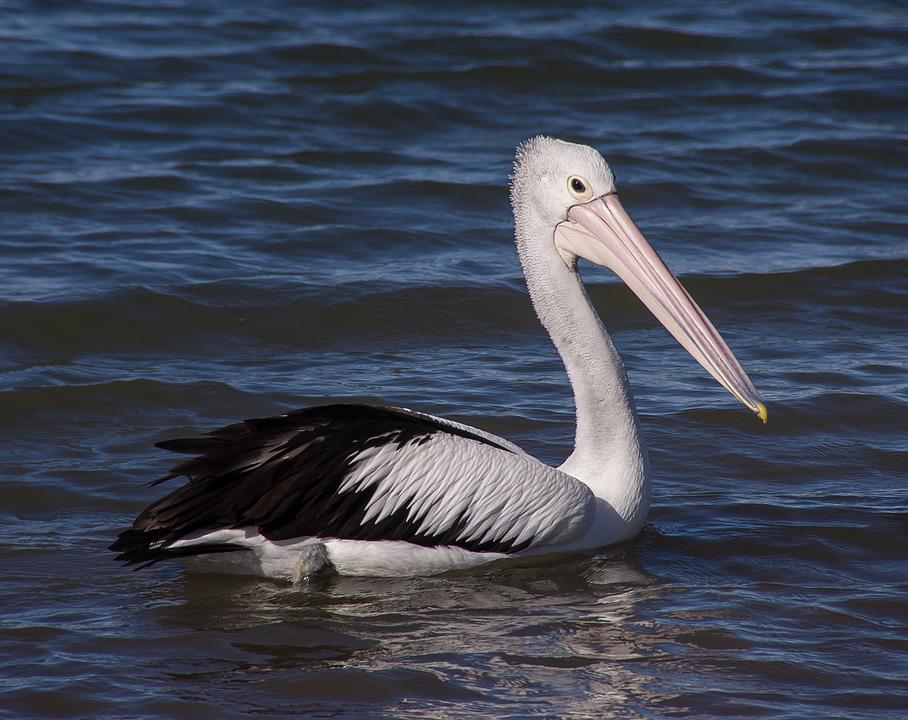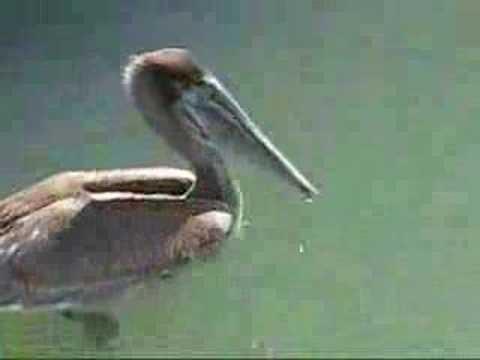The first image is the image on the left, the second image is the image on the right. Given the left and right images, does the statement "The bird in the left image that is furthest to the left is facing towards the left." hold true? Answer yes or no. No. The first image is the image on the left, the second image is the image on the right. Examine the images to the left and right. Is the description "The images in each set have no more than three birds in total." accurate? Answer yes or no. Yes. 